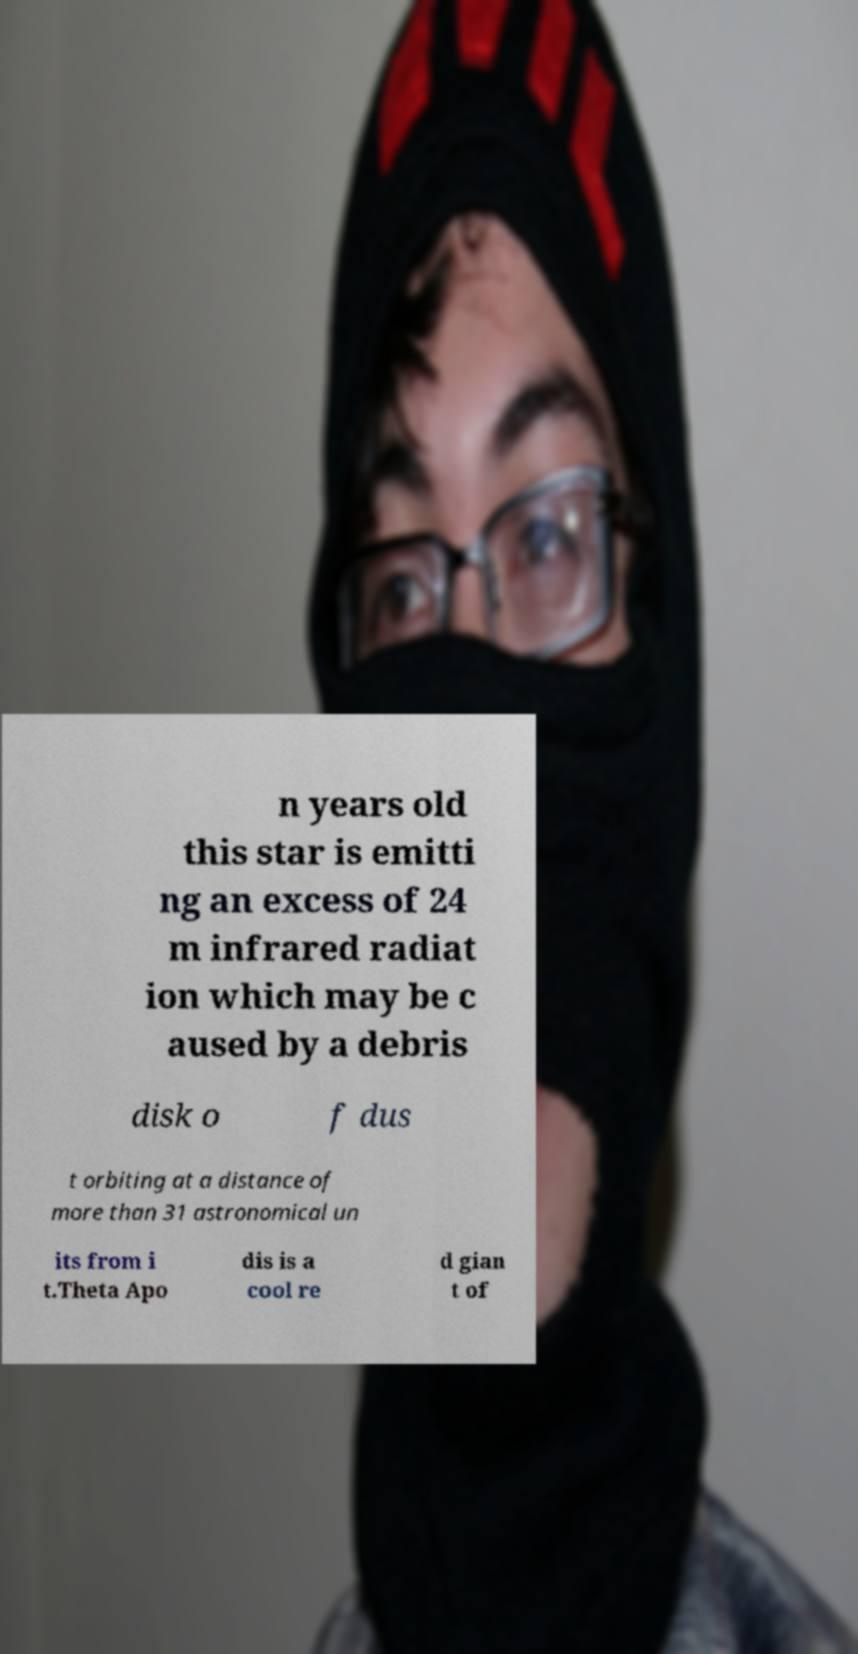Could you extract and type out the text from this image? n years old this star is emitti ng an excess of 24 m infrared radiat ion which may be c aused by a debris disk o f dus t orbiting at a distance of more than 31 astronomical un its from i t.Theta Apo dis is a cool re d gian t of 